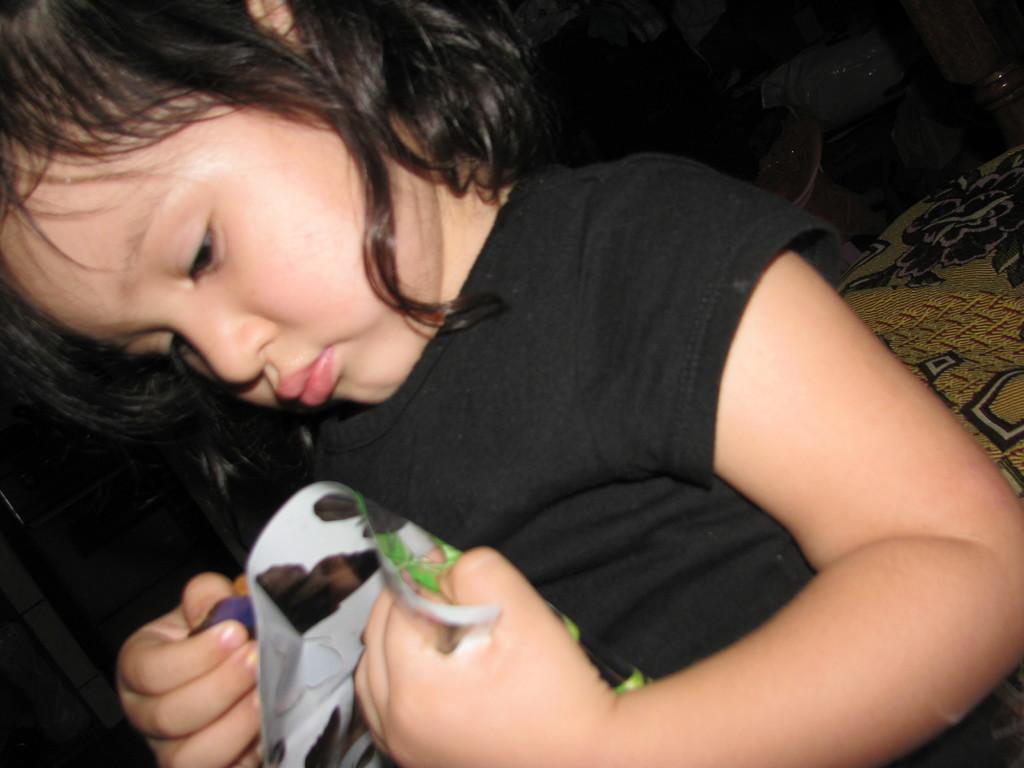How would you summarize this image in a sentence or two? In this image we can see a person and the person is holding an object. On the right side, we can see a cloth. The background of the image is dark. 